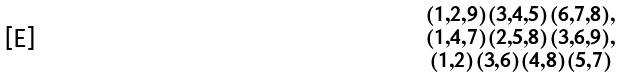Convert formula to latex. <formula><loc_0><loc_0><loc_500><loc_500>\begin{smallmatrix} ( 1 , 2 , 9 ) ( 3 , 4 , 5 ) ( 6 , 7 , 8 ) , \\ ( 1 , 4 , 7 ) ( 2 , 5 , 8 ) ( 3 , 6 , 9 ) , \\ ( 1 , 2 ) ( 3 , 6 ) ( 4 , 8 ) ( 5 , 7 ) \end{smallmatrix}</formula> 